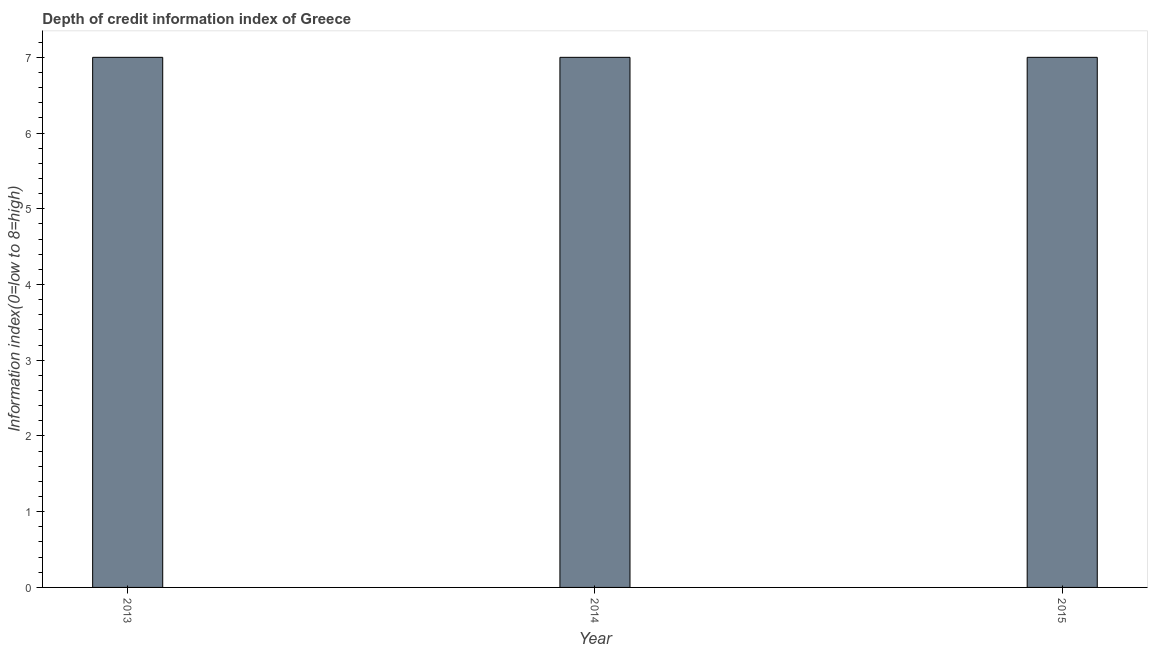Does the graph contain any zero values?
Keep it short and to the point. No. What is the title of the graph?
Offer a terse response. Depth of credit information index of Greece. What is the label or title of the Y-axis?
Offer a very short reply. Information index(0=low to 8=high). Across all years, what is the minimum depth of credit information index?
Your response must be concise. 7. In which year was the depth of credit information index maximum?
Give a very brief answer. 2013. In which year was the depth of credit information index minimum?
Offer a terse response. 2013. What is the difference between the depth of credit information index in 2013 and 2014?
Offer a very short reply. 0. What is the average depth of credit information index per year?
Make the answer very short. 7. What is the median depth of credit information index?
Provide a succinct answer. 7. In how many years, is the depth of credit information index greater than 6.4 ?
Provide a succinct answer. 3. Do a majority of the years between 2015 and 2014 (inclusive) have depth of credit information index greater than 4.2 ?
Provide a short and direct response. No. Is the difference between the depth of credit information index in 2014 and 2015 greater than the difference between any two years?
Offer a terse response. Yes. What is the difference between the highest and the second highest depth of credit information index?
Ensure brevity in your answer.  0. How many bars are there?
Offer a terse response. 3. Are all the bars in the graph horizontal?
Your answer should be compact. No. How many years are there in the graph?
Your answer should be compact. 3. What is the difference between two consecutive major ticks on the Y-axis?
Give a very brief answer. 1. Are the values on the major ticks of Y-axis written in scientific E-notation?
Your response must be concise. No. What is the Information index(0=low to 8=high) of 2014?
Your answer should be compact. 7. What is the Information index(0=low to 8=high) of 2015?
Offer a terse response. 7. What is the difference between the Information index(0=low to 8=high) in 2013 and 2014?
Your answer should be very brief. 0. What is the difference between the Information index(0=low to 8=high) in 2013 and 2015?
Offer a very short reply. 0. What is the ratio of the Information index(0=low to 8=high) in 2013 to that in 2014?
Your answer should be compact. 1. What is the ratio of the Information index(0=low to 8=high) in 2013 to that in 2015?
Your response must be concise. 1. What is the ratio of the Information index(0=low to 8=high) in 2014 to that in 2015?
Give a very brief answer. 1. 